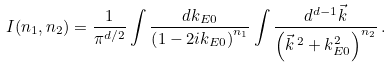<formula> <loc_0><loc_0><loc_500><loc_500>I ( n _ { 1 } , n _ { 2 } ) = \frac { 1 } { \pi ^ { d / 2 } } \int \frac { d k _ { E 0 } } { \left ( 1 - 2 i k _ { E 0 } \right ) ^ { n _ { 1 } } } \int \frac { d ^ { d - 1 } \vec { k } } { \left ( \vec { k } \, ^ { 2 } + k _ { E 0 } ^ { 2 } \right ) ^ { n _ { 2 } } } \, .</formula> 